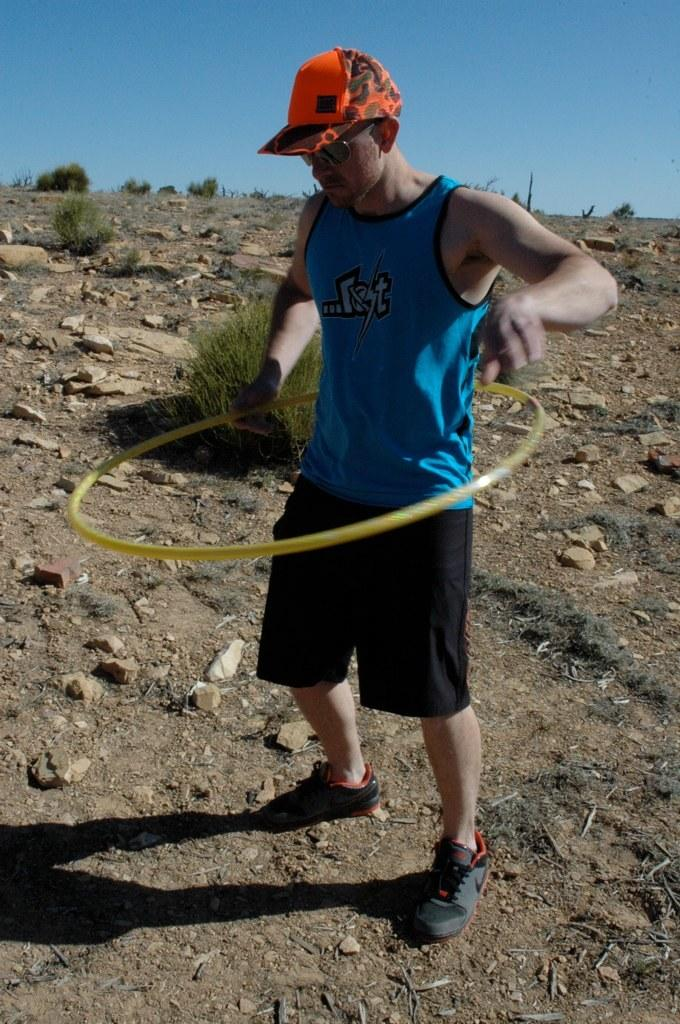What is the main subject of the image? There is a man in the image. What is the man doing in the image? The man is standing and holding a hula hoop. What can be seen behind the man in the image? There are bushes and rocks behind the man. What is visible in the background of the image? The sky is visible in the background of the image. How many spiders are crawling on the hula hoop in the image? There are no spiders visible in the image; the man is holding a hula hoop. What type of stick is the man using to perform his hula hoop routine in the image? There is no stick present in the image; the man is simply holding a hula hoop. 